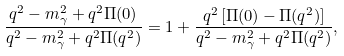<formula> <loc_0><loc_0><loc_500><loc_500>\frac { q ^ { 2 } - m _ { \gamma } ^ { 2 } + q ^ { 2 } \Pi ( 0 ) } { q ^ { 2 } - m _ { \gamma } ^ { 2 } + q ^ { 2 } \Pi ( q ^ { 2 } ) } = 1 + \frac { q ^ { 2 } \, [ \Pi ( 0 ) - \Pi ( q ^ { 2 } ) ] } { q ^ { 2 } - m _ { \gamma } ^ { 2 } + q ^ { 2 } \Pi ( q ^ { 2 } ) } ,</formula> 